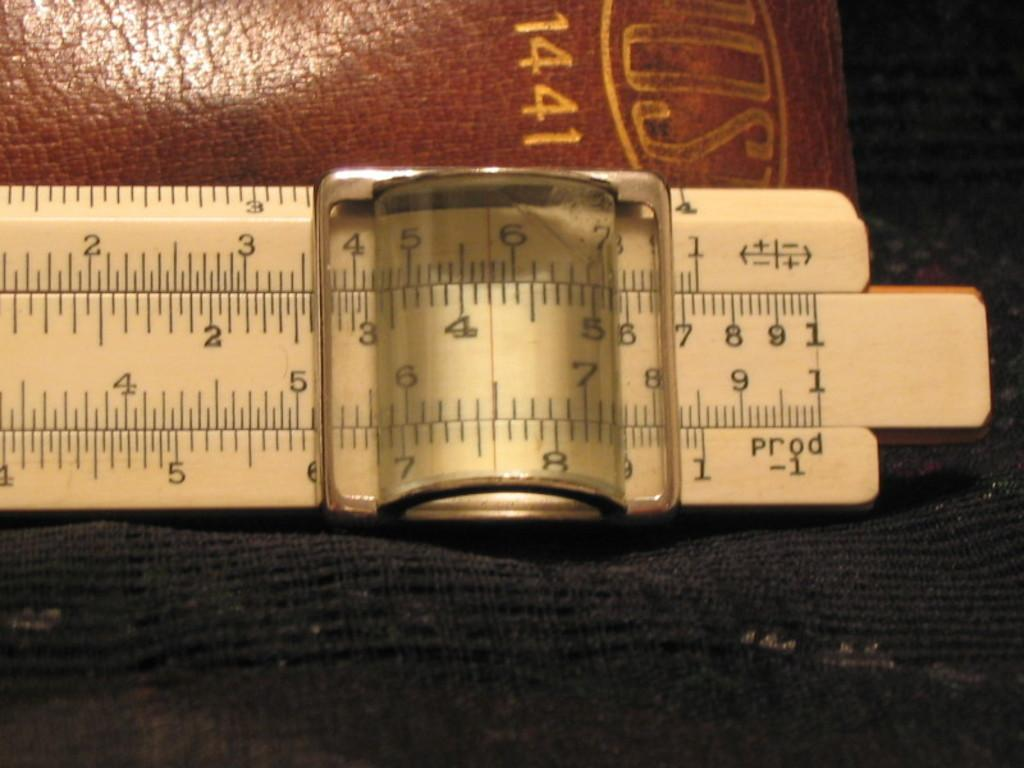<image>
Write a terse but informative summary of the picture. A leather case with the number 1441 on it sits behind a measuring device. 